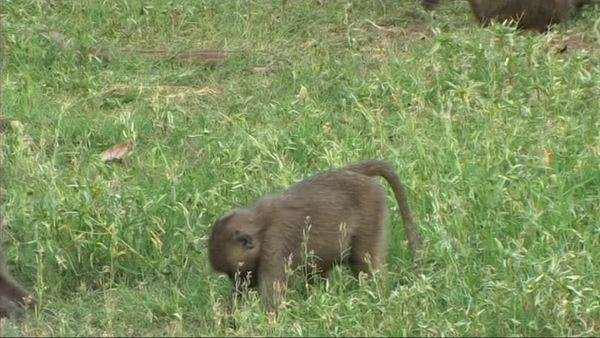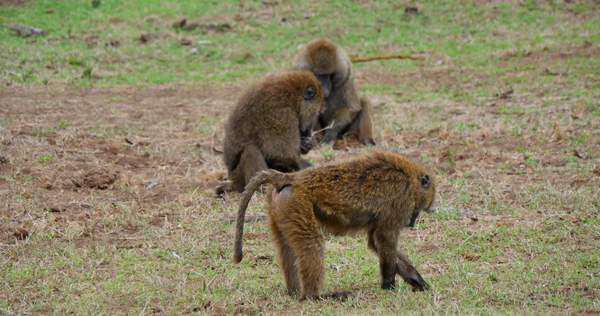The first image is the image on the left, the second image is the image on the right. Considering the images on both sides, is "there are no more than 4 baboons in the pair of images" valid? Answer yes or no. Yes. The first image is the image on the left, the second image is the image on the right. Examine the images to the left and right. Is the description "A monkey in the image on the right happens to be holding something." accurate? Answer yes or no. No. 